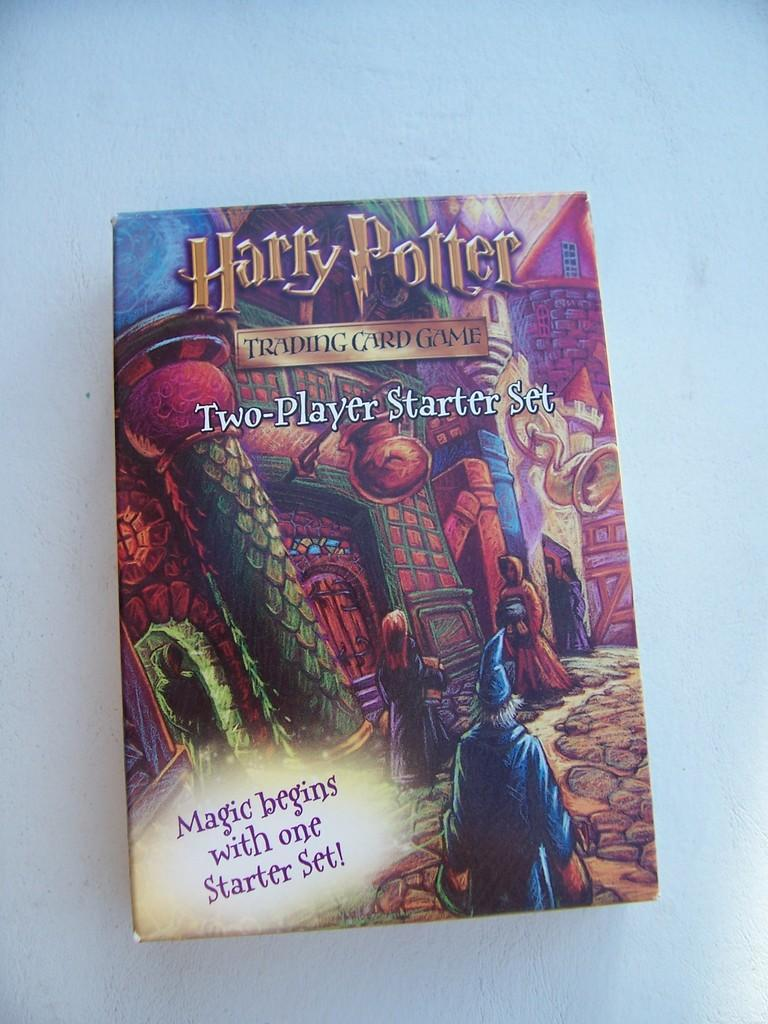<image>
Relay a brief, clear account of the picture shown. Harry Potter trading card game sitting alone on a table. 